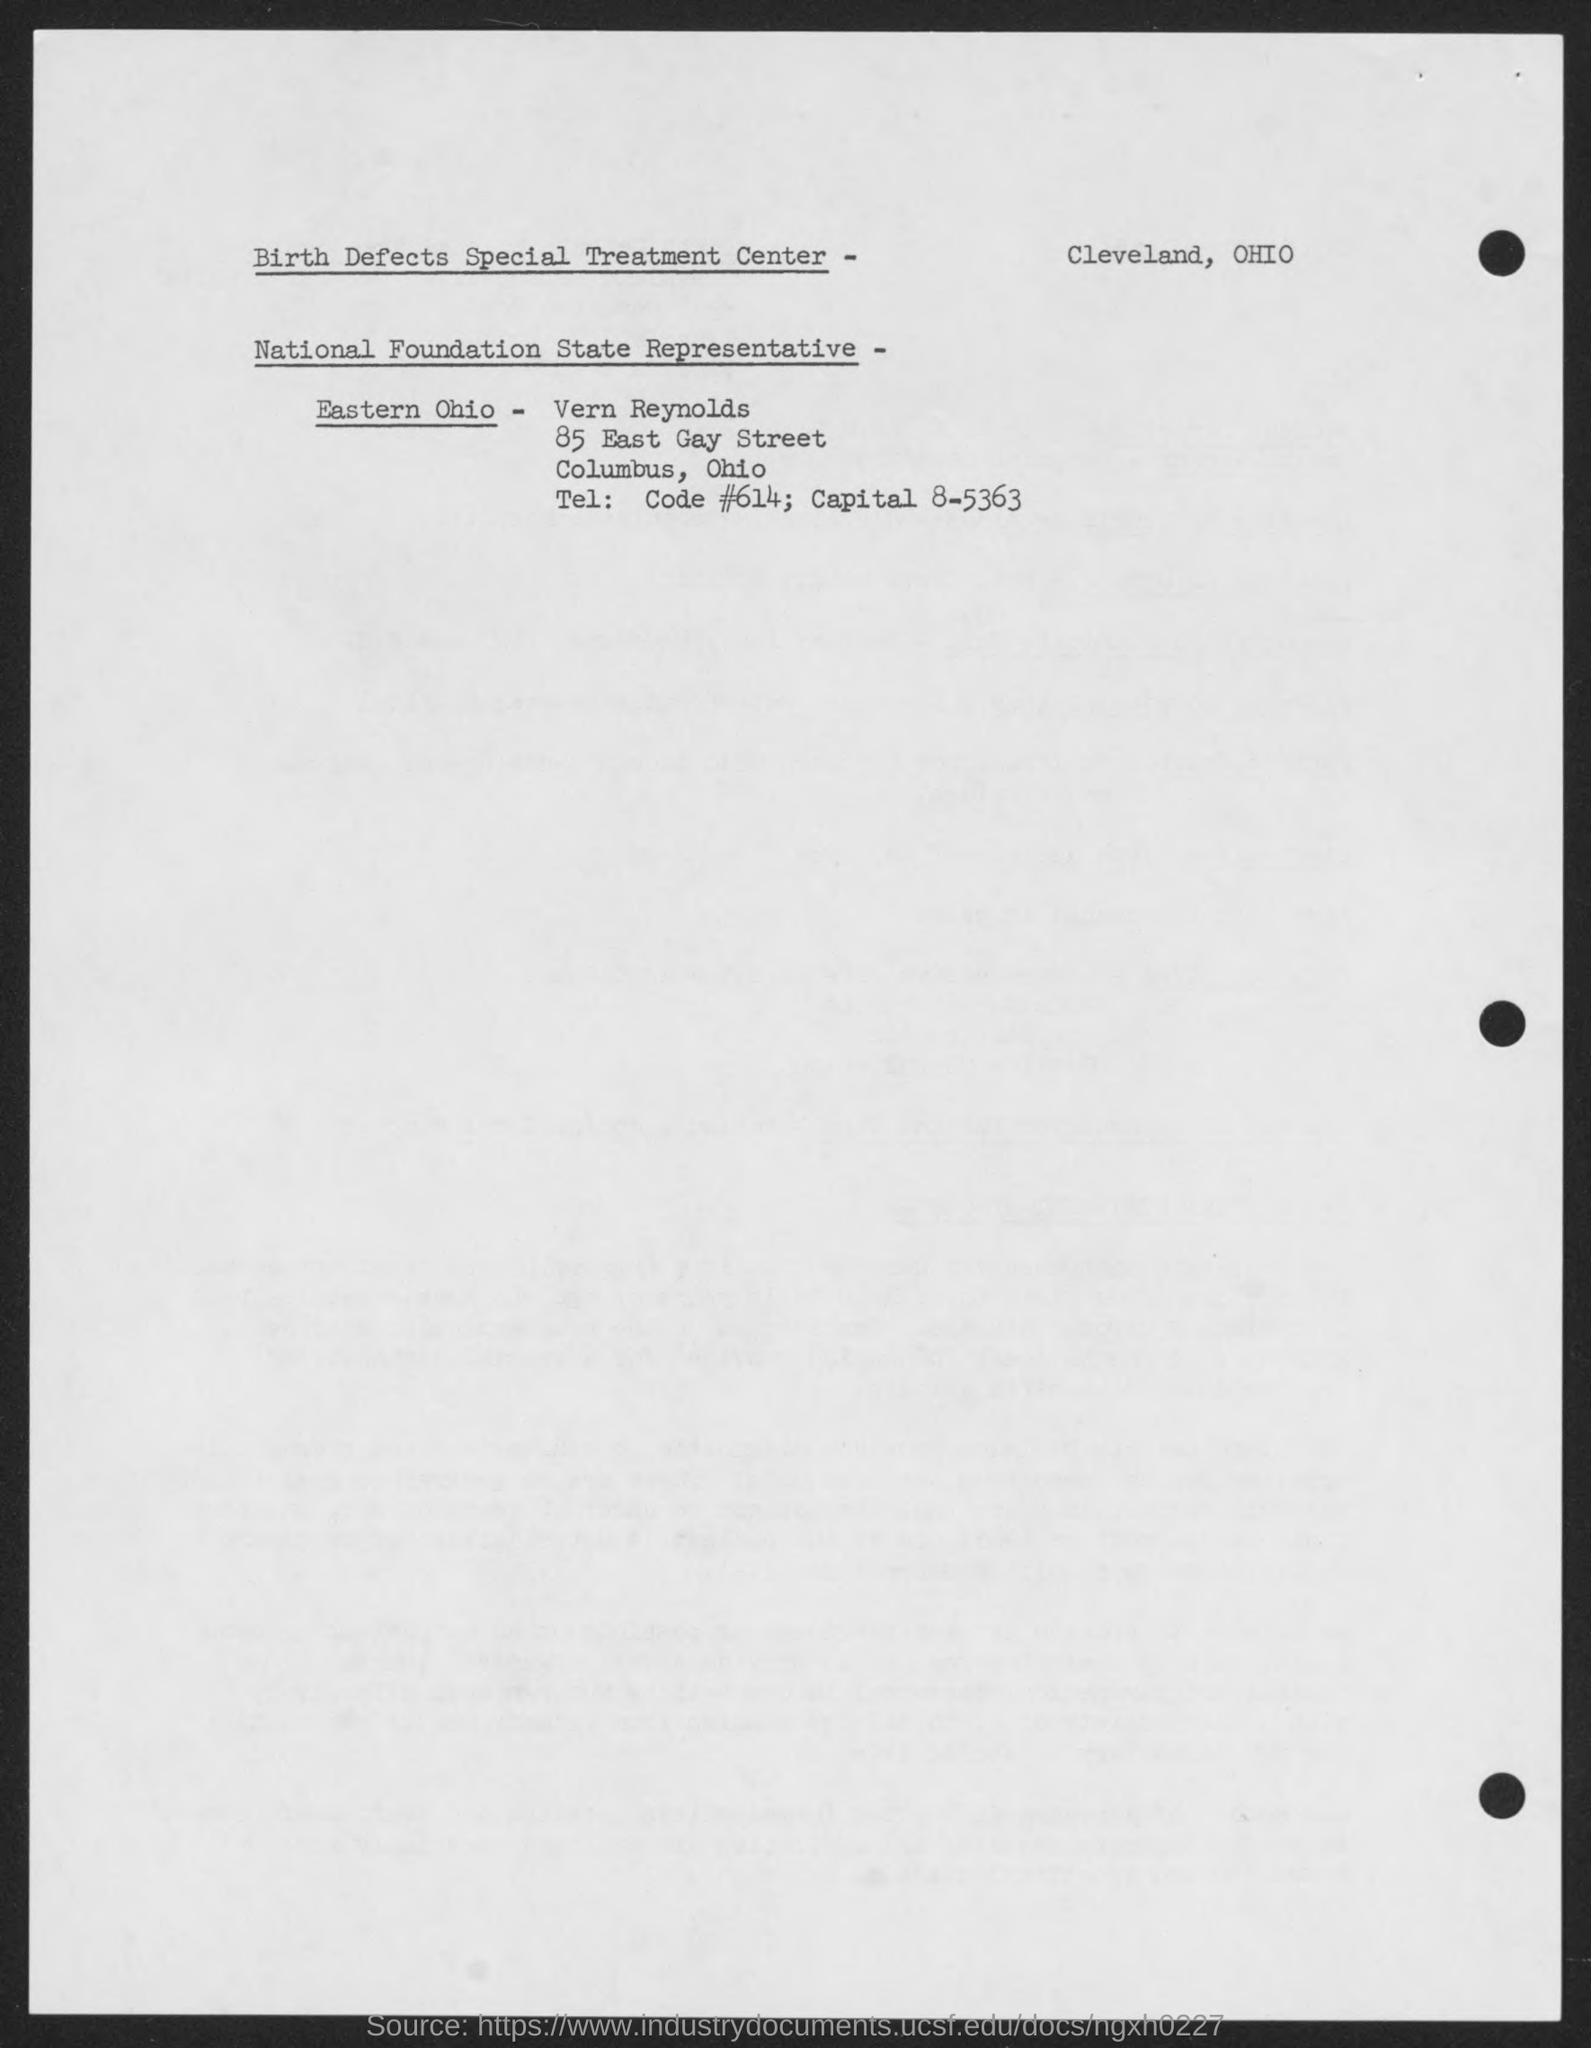Who is the National Foundation State Representative-Eastern Ohio?
Keep it short and to the point. Vern Reynolds. 